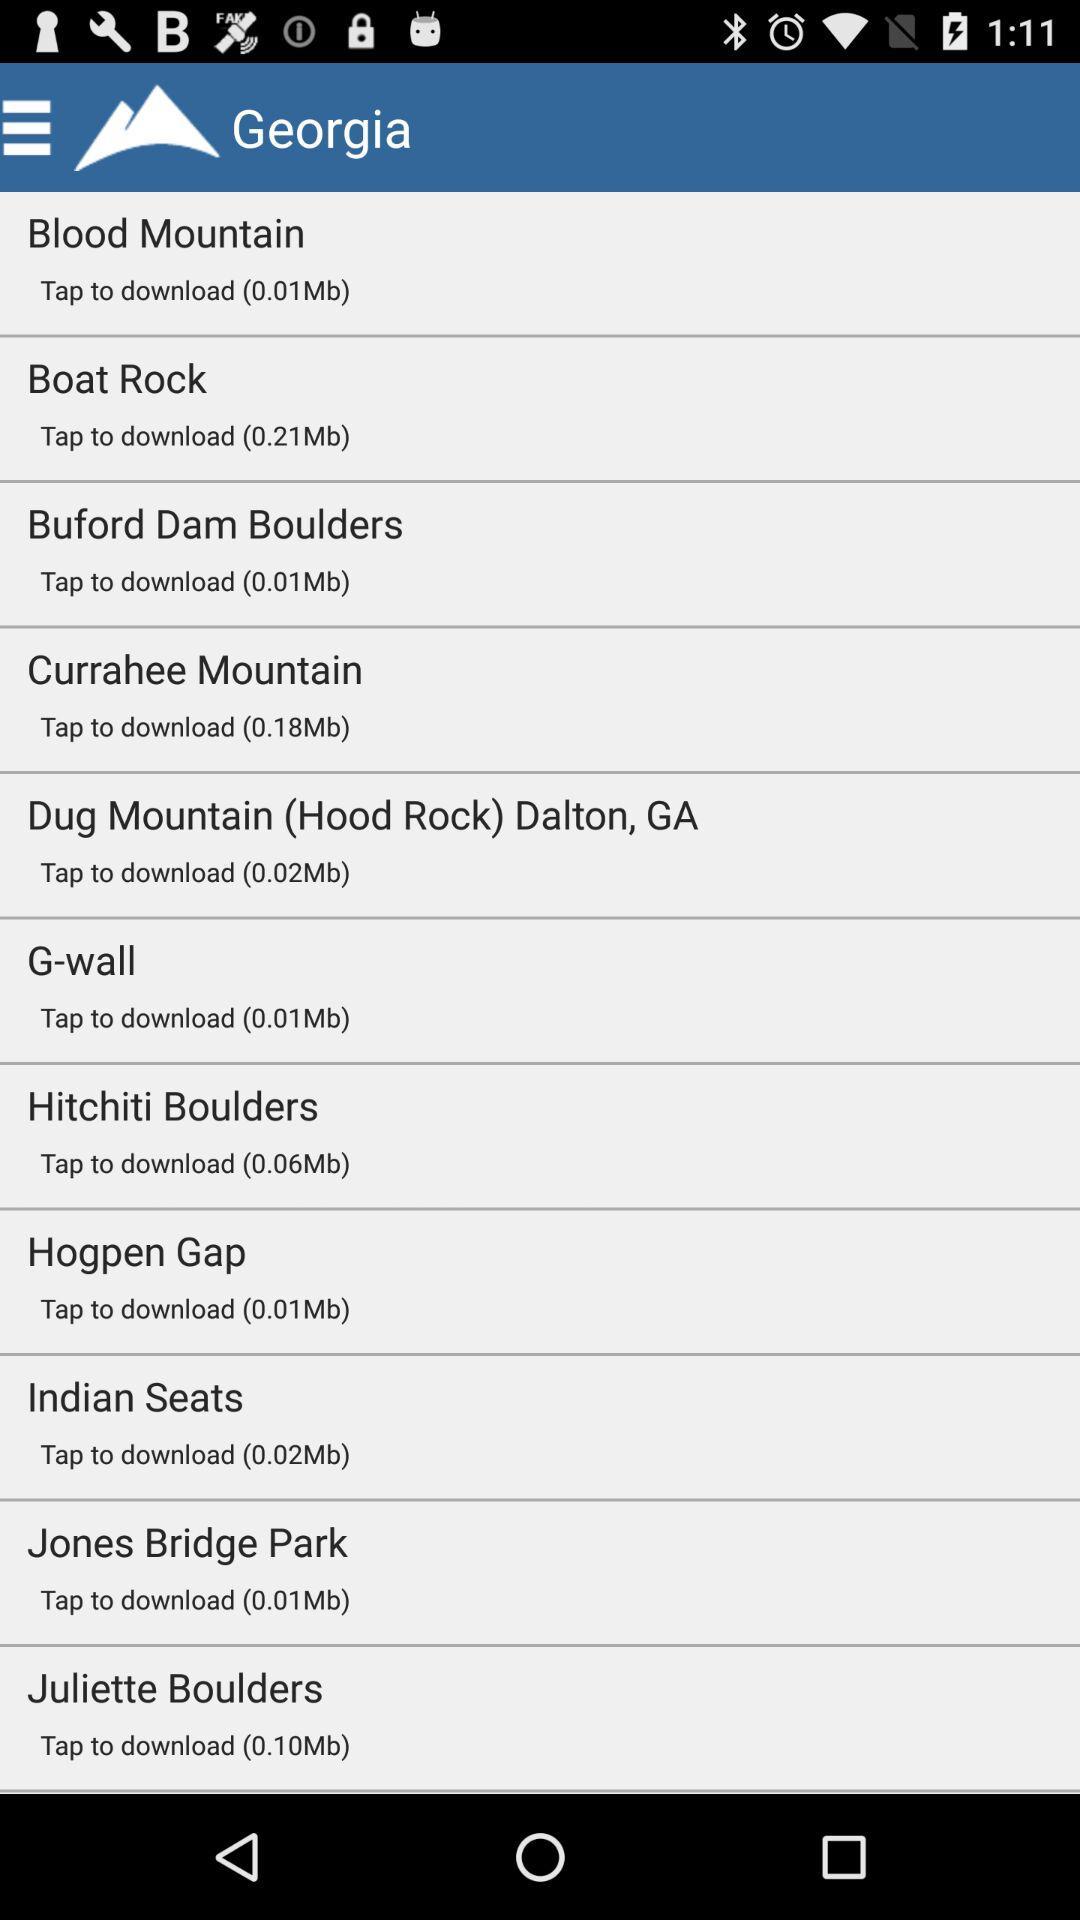Which song has 0.18 Mb to download? The song that has 0.18 Mb to download is "Currahee Mountain". 